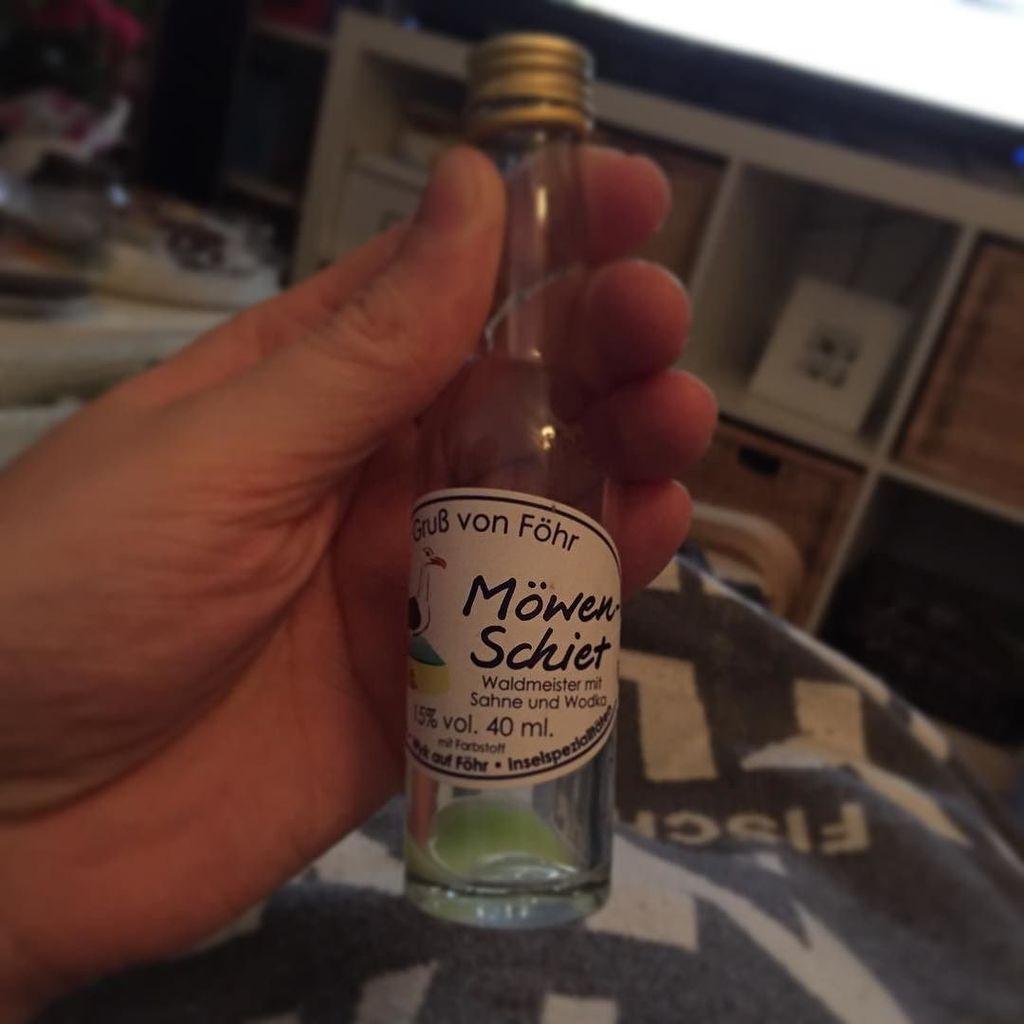What is the brand?
Provide a succinct answer. Mowen schiet. 